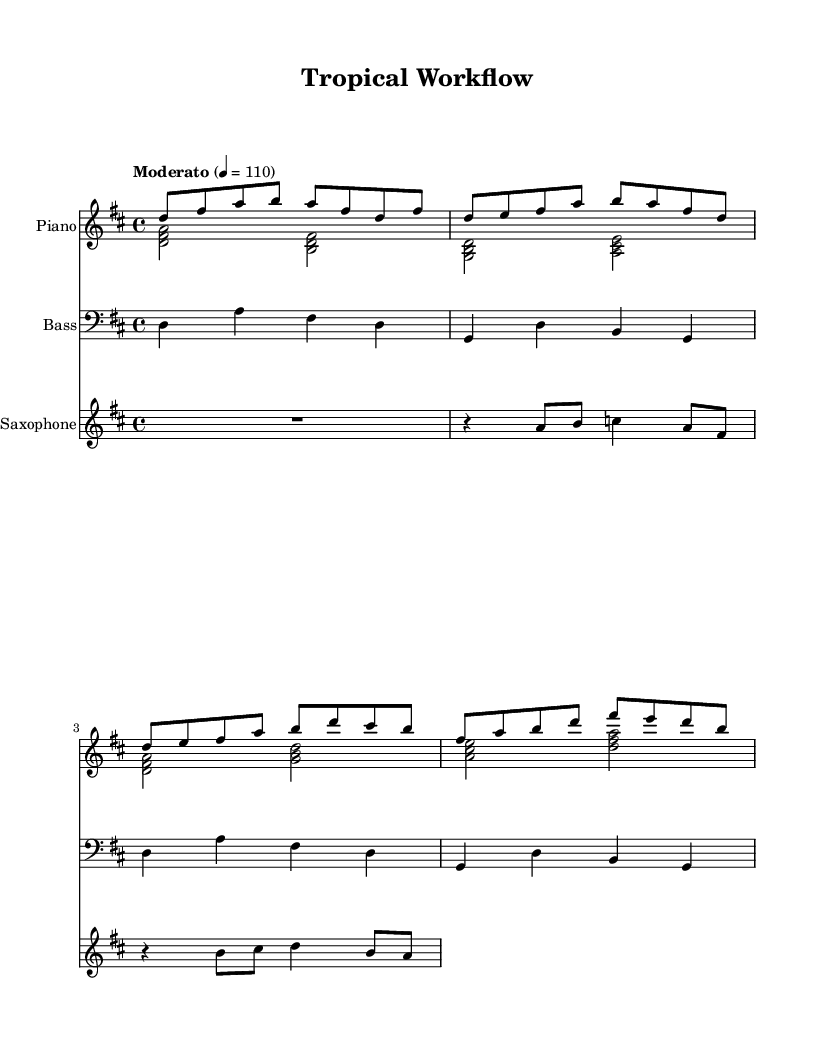What is the key signature of this music? The key signature is D major, which has two sharps (F# and C#). We can identify the key signature by looking at the area after the clef, where the sharps are indicated.
Answer: D major What is the time signature of this music? The time signature is 4/4, which is indicated at the beginning of the score after the key signature. This means there are four beats in each measure and the quarter note gets one beat.
Answer: 4/4 What is the tempo marking for this piece? The tempo marking states "Moderato" with a metronome marking of 110. This indicates a moderately paced tempo of 110 beats per minute. The tempo information is located near the start of the music.
Answer: Moderato 110 Which instrument primarily carries the melody in this score? The saxophone primarily carries the melody, as it has melodic fills written in the treble clef and is the only instrument that has a dedicated melody line in this arrangement.
Answer: Saxophone How many measures are there in the intro section? There are four measures in the intro section, as indicated by the grouping of notes before entering the verse. Each measure contains different notes but is clearly separated within the notation.
Answer: Four measures What type of musical structure is primarily used in this Latin jazz piece? The musical structure primarily follows a verse-chorus format. This can be inferred from the labels 'Verse' and 'Chorus' marked in the piano right-hand part, indicating the different sections of the composition.
Answer: Verse-Chorus What is the role of the bass in this arrangement? The role of the bass is to provide foundational harmony and rhythm. It plays root notes and follows the chordal structure, which supports the harmony while maintaining the groove of the piece, typical of jazz fusion arrangements.
Answer: Foundation and rhythm 